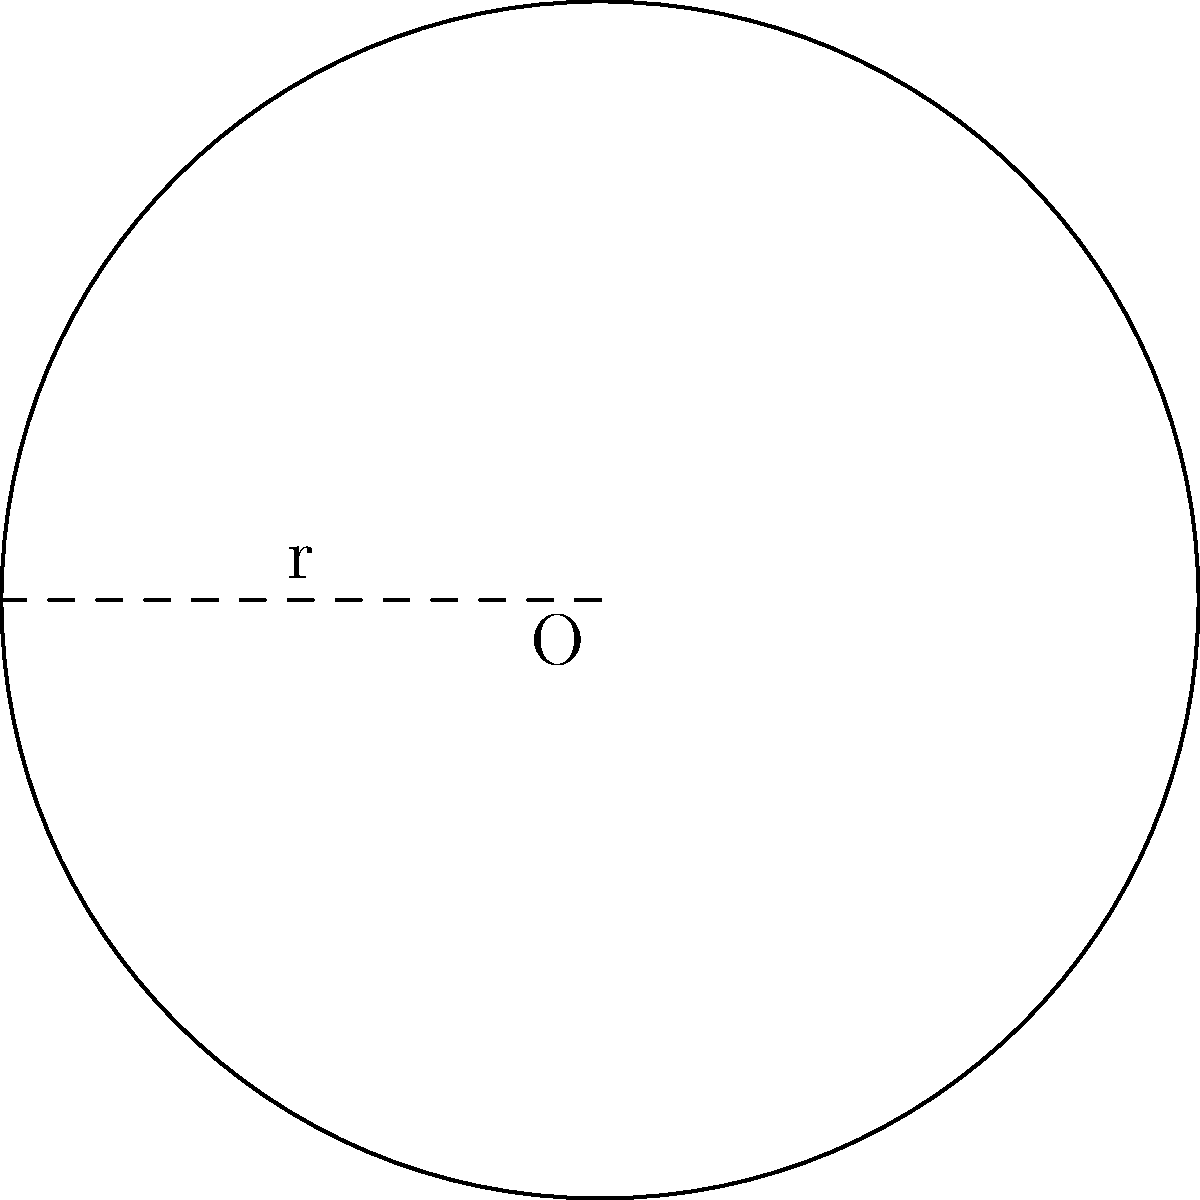A circular pasture on a newly acquired ranch property has a radius of 150 yards. What is the total area of this pasture in square yards? To calculate the area of a circular pasture, we use the formula for the area of a circle:

$$A = \pi r^2$$

Where:
$A$ = Area of the circle
$\pi$ = Pi (approximately 3.14159)
$r$ = Radius of the circle

Given:
Radius ($r$) = 150 yards

Step 1: Substitute the given radius into the formula
$$A = \pi (150)^2$$

Step 2: Calculate the square of the radius
$$A = \pi (22,500)$$

Step 3: Multiply by π
$$A = 70,685.83$$

Therefore, the area of the circular pasture is approximately 70,685.83 square yards.
Answer: 70,685.83 square yards 